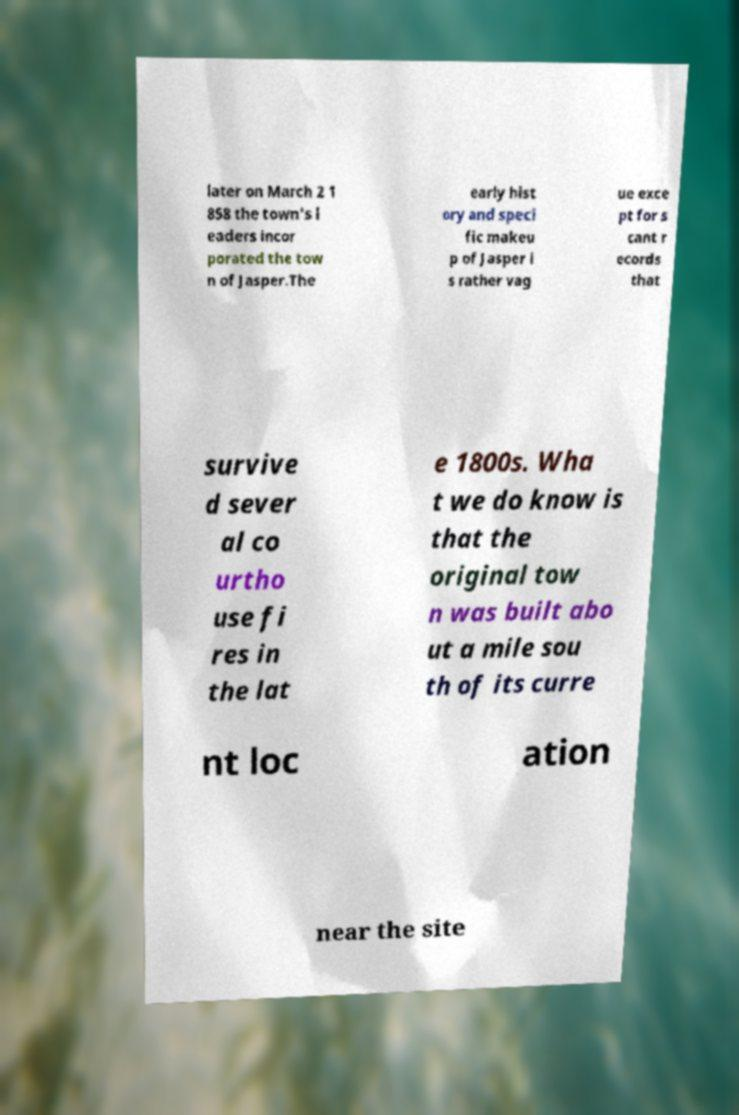What messages or text are displayed in this image? I need them in a readable, typed format. later on March 2 1 858 the town's l eaders incor porated the tow n of Jasper.The early hist ory and speci fic makeu p of Jasper i s rather vag ue exce pt for s cant r ecords that survive d sever al co urtho use fi res in the lat e 1800s. Wha t we do know is that the original tow n was built abo ut a mile sou th of its curre nt loc ation near the site 